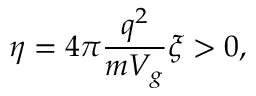<formula> <loc_0><loc_0><loc_500><loc_500>\eta = 4 \pi \frac { q ^ { 2 } } { m V _ { g } } \xi > 0 ,</formula> 